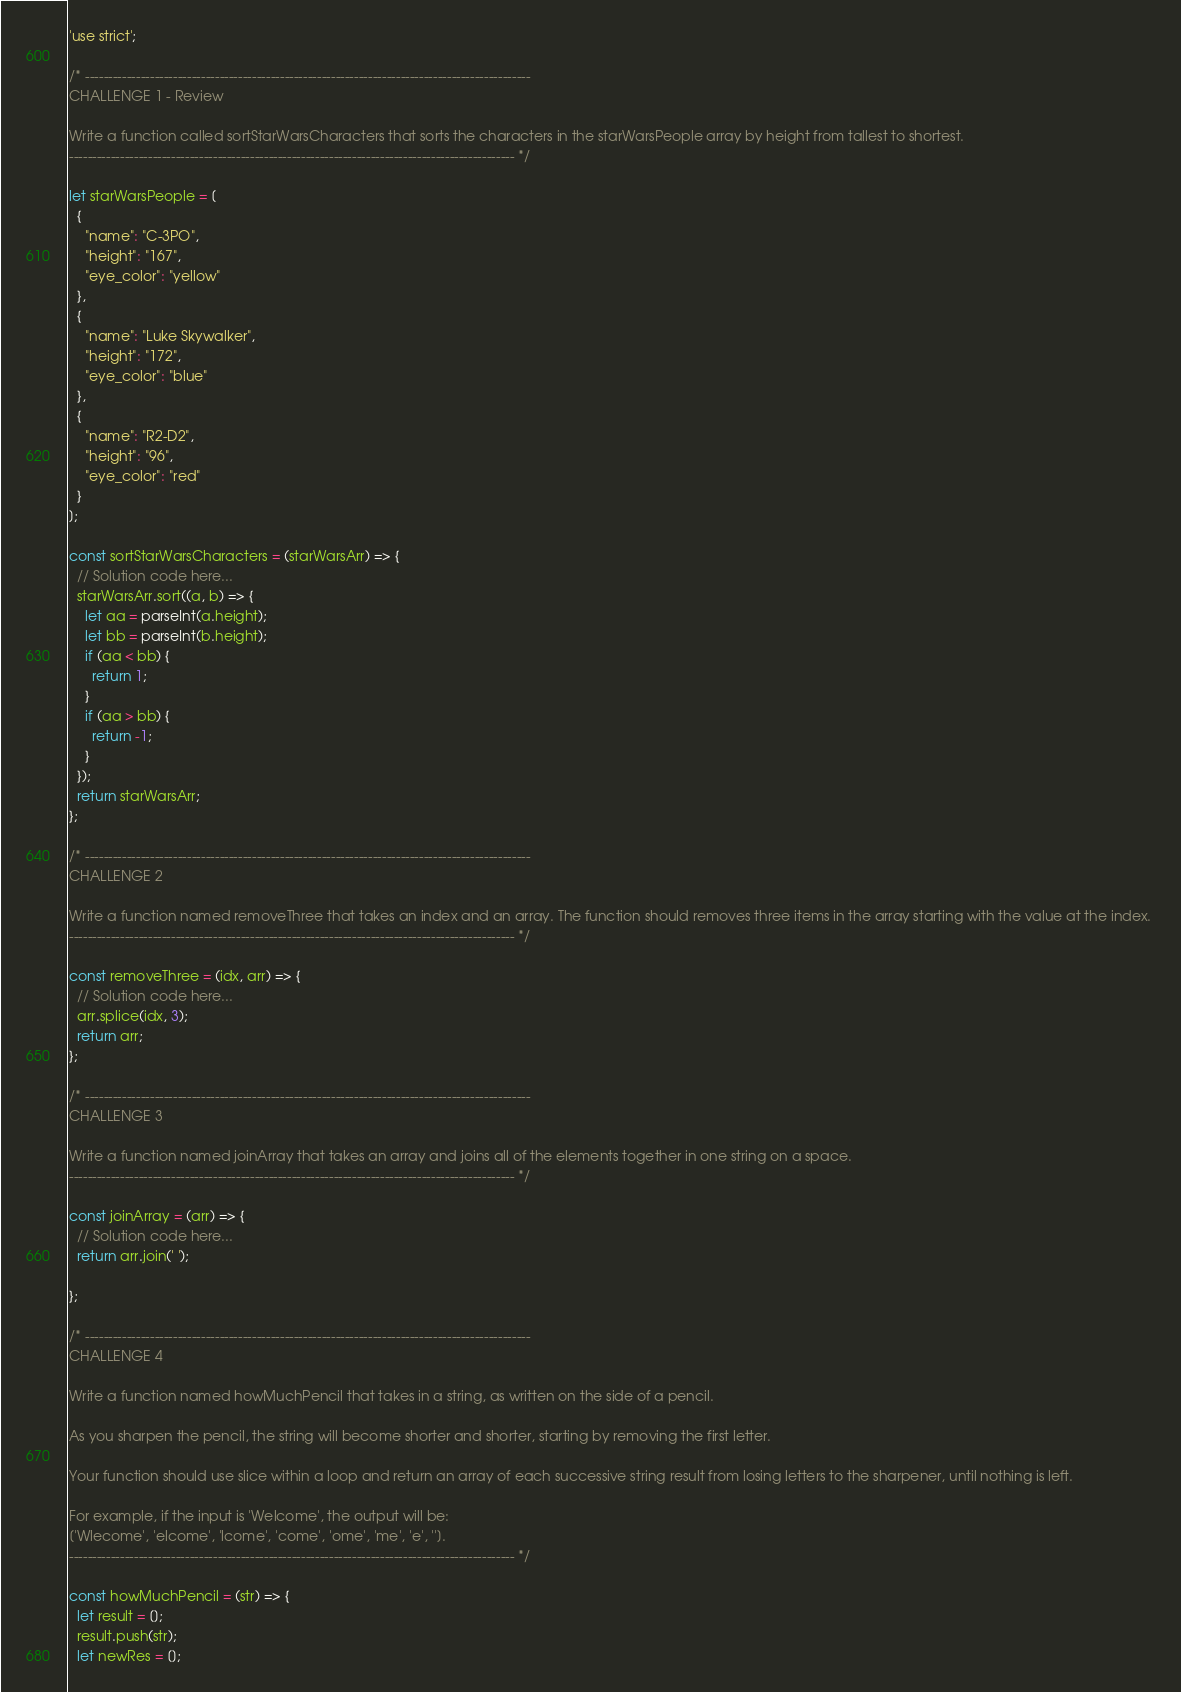<code> <loc_0><loc_0><loc_500><loc_500><_JavaScript_>'use strict';

/* ------------------------------------------------------------------------------------------------
CHALLENGE 1 - Review

Write a function called sortStarWarsCharacters that sorts the characters in the starWarsPeople array by height from tallest to shortest.
------------------------------------------------------------------------------------------------ */

let starWarsPeople = [
  {
    "name": "C-3PO",
    "height": "167",
    "eye_color": "yellow"
  },
  {
    "name": "Luke Skywalker",
    "height": "172",
    "eye_color": "blue"
  },
  {
    "name": "R2-D2",
    "height": "96",
    "eye_color": "red"
  }
];

const sortStarWarsCharacters = (starWarsArr) => {
  // Solution code here...
  starWarsArr.sort((a, b) => {
    let aa = parseInt(a.height);
    let bb = parseInt(b.height);
    if (aa < bb) {
      return 1;
    }
    if (aa > bb) {
      return -1;
    }
  });
  return starWarsArr;
};

/* ------------------------------------------------------------------------------------------------
CHALLENGE 2

Write a function named removeThree that takes an index and an array. The function should removes three items in the array starting with the value at the index. 
------------------------------------------------------------------------------------------------ */

const removeThree = (idx, arr) => {
  // Solution code here...
  arr.splice(idx, 3);
  return arr;
};

/* ------------------------------------------------------------------------------------------------
CHALLENGE 3

Write a function named joinArray that takes an array and joins all of the elements together in one string on a space.
------------------------------------------------------------------------------------------------ */

const joinArray = (arr) => {
  // Solution code here...
  return arr.join(' ');
  
};

/* ------------------------------------------------------------------------------------------------
CHALLENGE 4

Write a function named howMuchPencil that takes in a string, as written on the side of a pencil.

As you sharpen the pencil, the string will become shorter and shorter, starting by removing the first letter.

Your function should use slice within a loop and return an array of each successive string result from losing letters to the sharpener, until nothing is left.

For example, if the input is 'Welcome', the output will be:
['Wlecome', 'elcome', 'lcome', 'come', 'ome', 'me', 'e', ''].
------------------------------------------------------------------------------------------------ */

const howMuchPencil = (str) => {
  let result = [];
  result.push(str);
  let newRes = [];</code> 